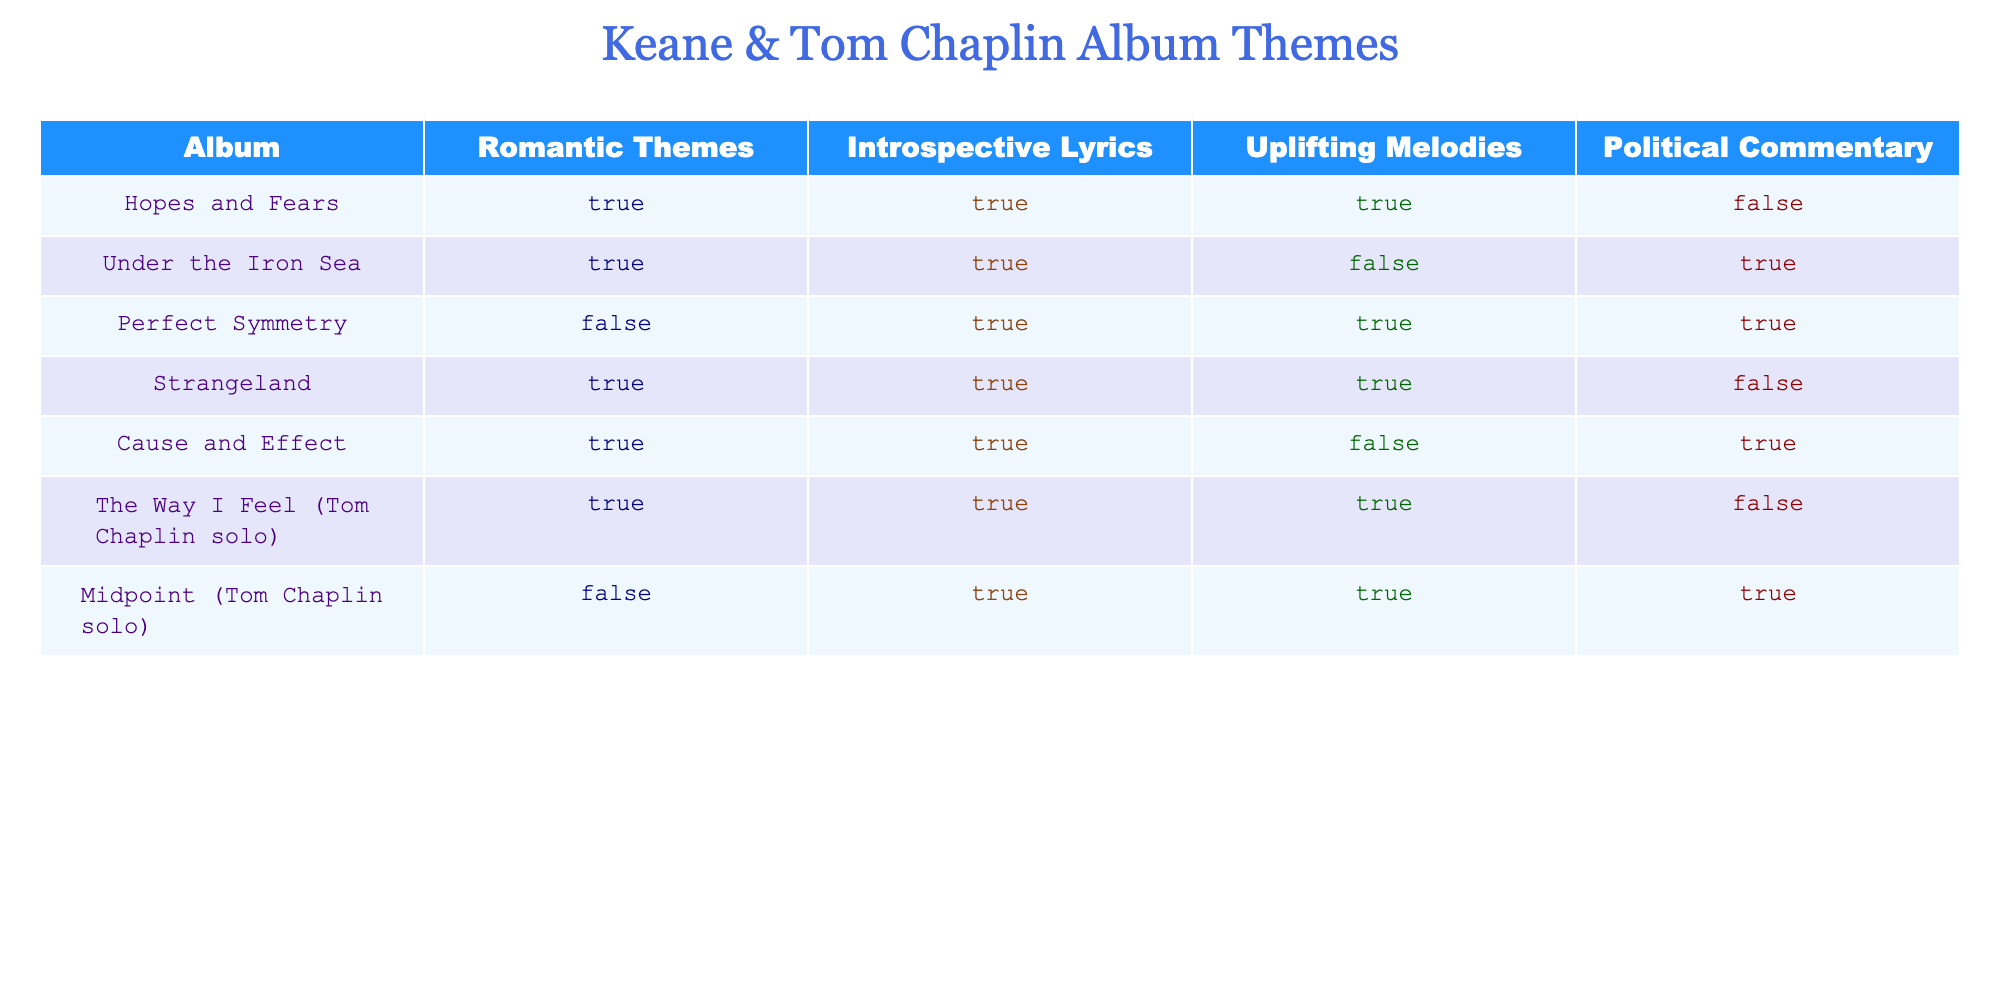What albums feature both romantic themes and uplifting melodies? In the table, I look for rows where both the "Romantic Themes" and "Uplifting Melodies" columns are marked TRUE. The albums that meet this criterion are Hopes and Fears, Strangeland, and The Way I Feel.
Answer: Hopes and Fears, Strangeland, The Way I Feel Is there any album that has neither uplifting melodies nor political commentary? I need to check the columns "Uplifting Melodies" and "Political Commentary" for FALSE values in the same row. The album Perfect Symmetry has FALSE in "Uplifting Melodies" and TRUE in "Political Commentary," not invalidating the question. However, the album Midpoint has FALSE for "Political Commentary" but TRUE in "Uplifting Melodies." Thus, no album fits the requirement of having both as FALSE in those columns.
Answer: No Which album has the most themes present, and how many themes does it have? I will count the TRUE values for each album. By examining the rows, Hopes and Fears, Strangeland, and The Way I Feel have 3 TRUE values. Other albums have fewer TRUE values. Therefore, the album with the most themes is Hopes and Fears, Strangeland, and The Way I Feel, each with 3 themes.
Answer: Hopes and Fears, Strangeland, The Way I Feel; 3 themes Do any albums contain political commentary without introspective lyrics? I will check for rows that have TRUE under "Political Commentary" and FALSE under "Introspective Lyrics." Under the analysis, the albums Under the Iron Sea and Cause and Effect both show TRUE in political commentary and FALSE in introspective lyrics.
Answer: Yes, Under the Iron Sea, Cause and Effect Are there more solo albums with uplifting melodies than band albums without romantic themes? I will count the solo albums (The Way I Feel and Midpoint) with TRUE under "Uplifting Melodies," finding 2. In contrast, the band albums that lack romantic themes are Perfect Symmetry (FALSE) and Midpoint (FALSE), resulting in 1 band album lacking romantic themes. So, 2 solo albums with uplifting melodies is greater than 1 band album without romantic themes.
Answer: Yes 